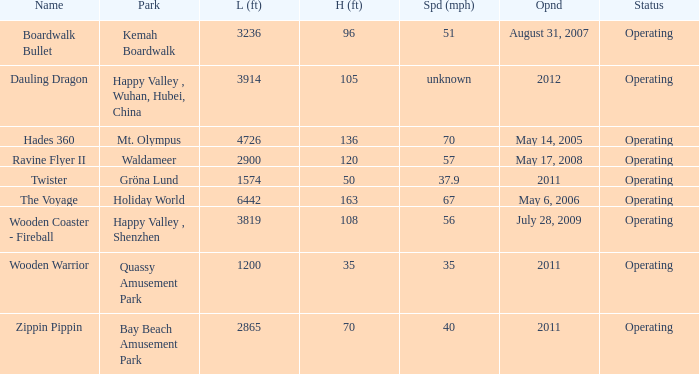How fast is the coaster that is 163 feet tall 67.0. 